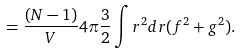Convert formula to latex. <formula><loc_0><loc_0><loc_500><loc_500>= \frac { ( N - 1 ) } { V } 4 \pi \frac { 3 } { 2 } \int r ^ { 2 } d r ( f ^ { 2 } + g ^ { 2 } ) .</formula> 